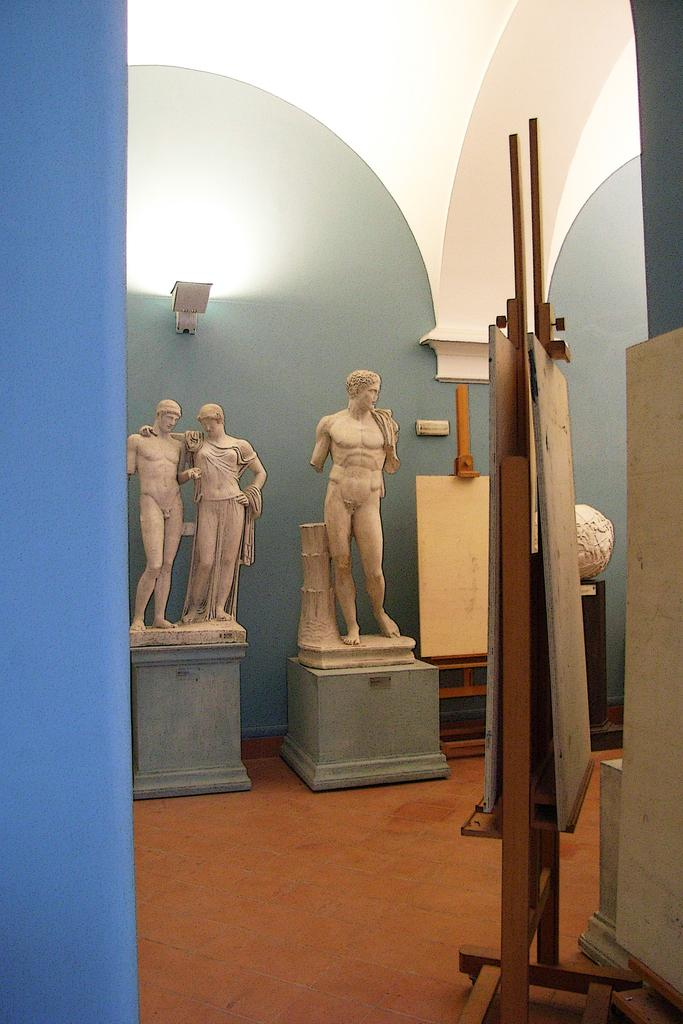What type of art is present in the image? There are sculptures in the image. What surface can be seen beneath the sculptures? There is a floor visible in the image. What material is present in the image that is used for displaying information or artwork? There are boards in the image. What architectural feature is visible in the background of the image? There is a wall in the background of the image. What is the source of illumination in the image? There is light in the image. What type of teeth can be seen in the image? There are no teeth present in the image. How many cats are visible in the image? There are no cats present in the image. 